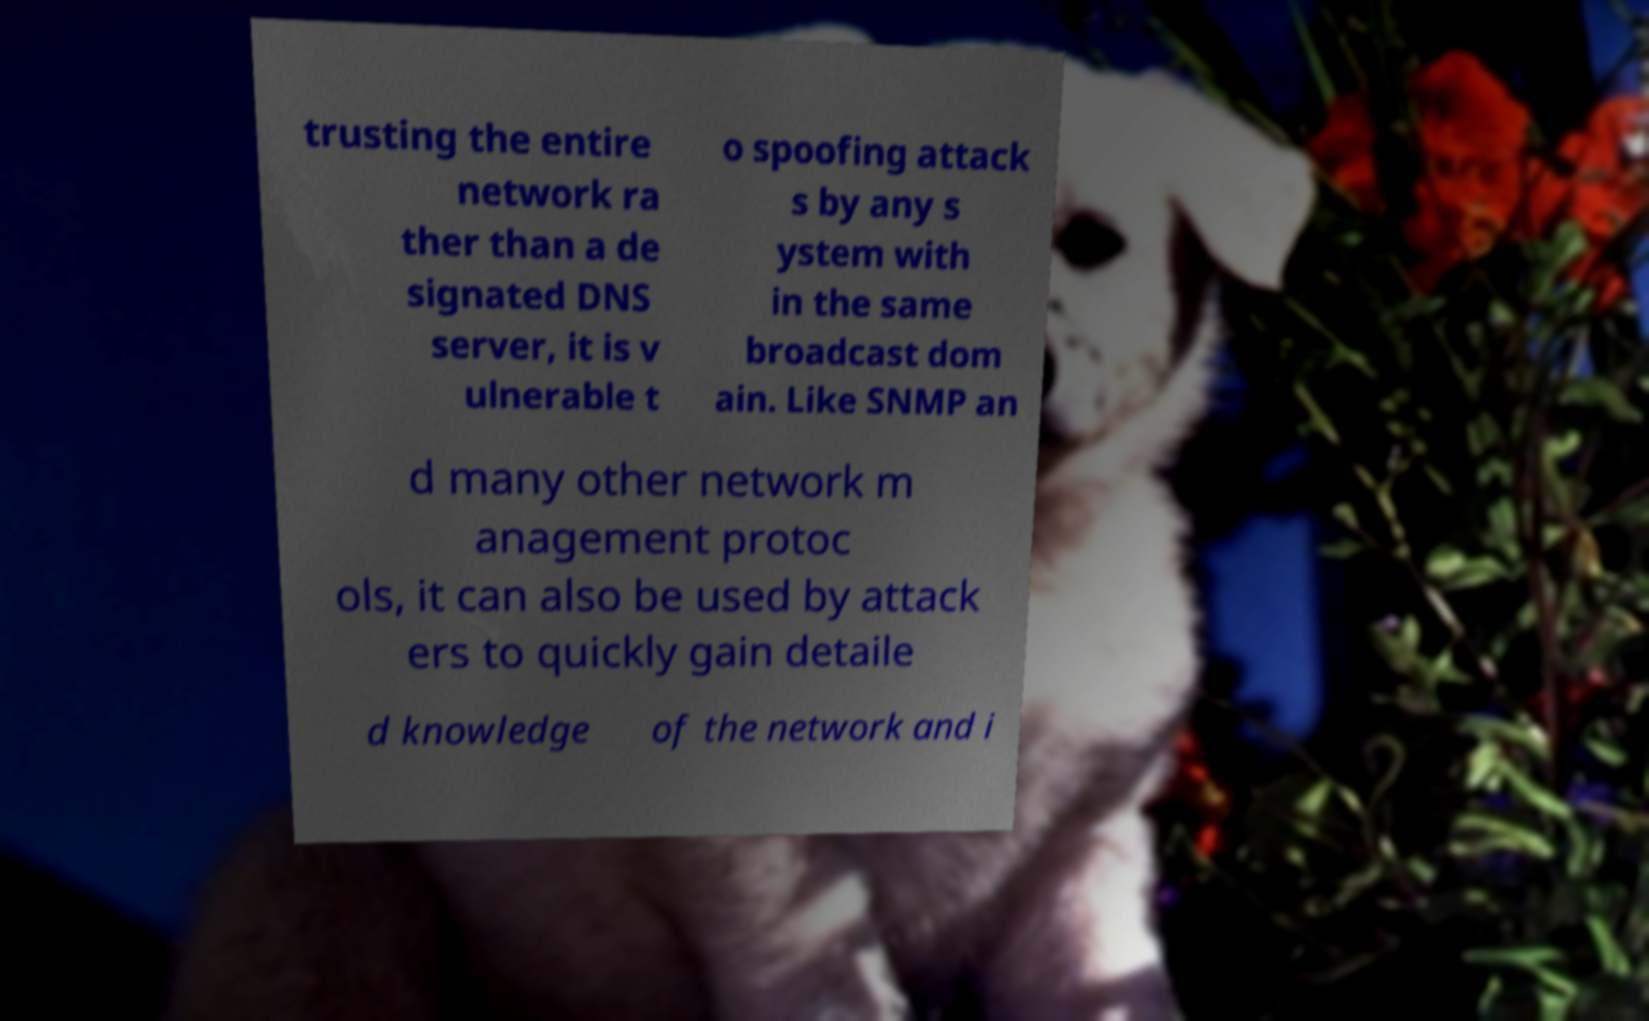Please identify and transcribe the text found in this image. trusting the entire network ra ther than a de signated DNS server, it is v ulnerable t o spoofing attack s by any s ystem with in the same broadcast dom ain. Like SNMP an d many other network m anagement protoc ols, it can also be used by attack ers to quickly gain detaile d knowledge of the network and i 